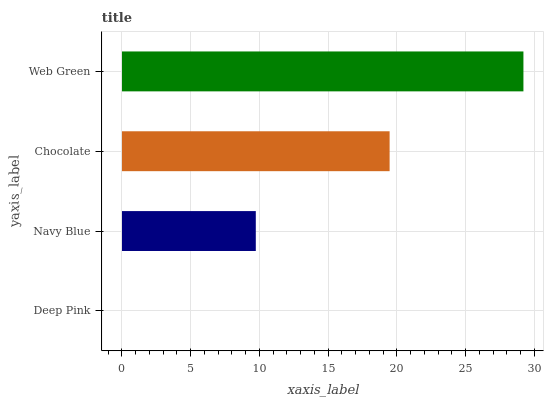Is Deep Pink the minimum?
Answer yes or no. Yes. Is Web Green the maximum?
Answer yes or no. Yes. Is Navy Blue the minimum?
Answer yes or no. No. Is Navy Blue the maximum?
Answer yes or no. No. Is Navy Blue greater than Deep Pink?
Answer yes or no. Yes. Is Deep Pink less than Navy Blue?
Answer yes or no. Yes. Is Deep Pink greater than Navy Blue?
Answer yes or no. No. Is Navy Blue less than Deep Pink?
Answer yes or no. No. Is Chocolate the high median?
Answer yes or no. Yes. Is Navy Blue the low median?
Answer yes or no. Yes. Is Web Green the high median?
Answer yes or no. No. Is Chocolate the low median?
Answer yes or no. No. 